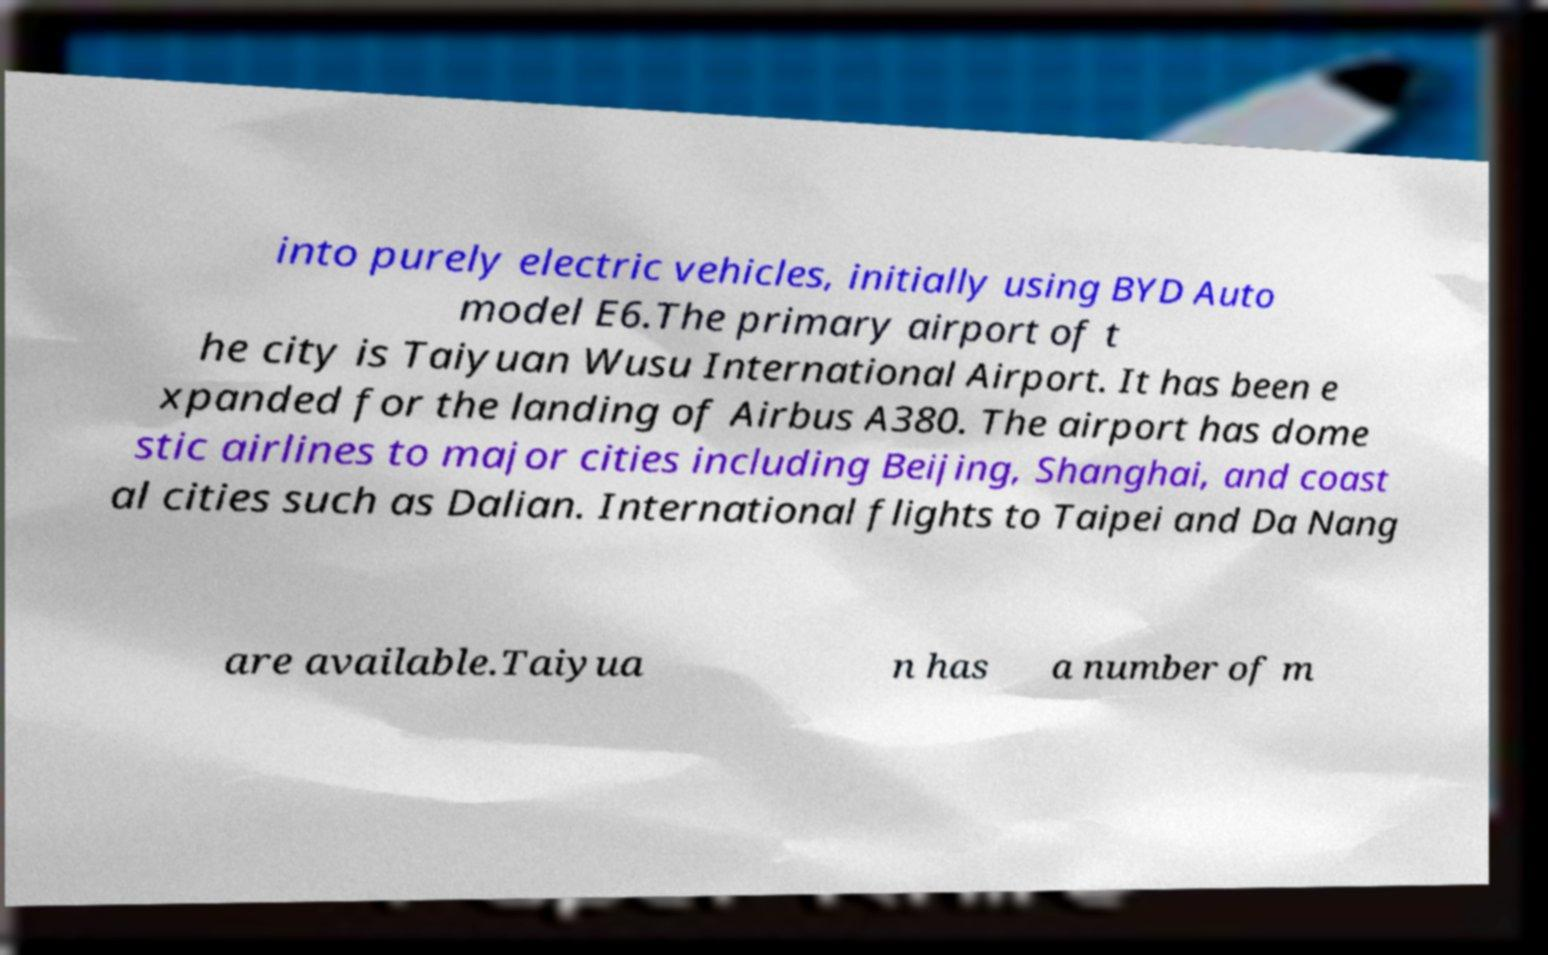For documentation purposes, I need the text within this image transcribed. Could you provide that? into purely electric vehicles, initially using BYD Auto model E6.The primary airport of t he city is Taiyuan Wusu International Airport. It has been e xpanded for the landing of Airbus A380. The airport has dome stic airlines to major cities including Beijing, Shanghai, and coast al cities such as Dalian. International flights to Taipei and Da Nang are available.Taiyua n has a number of m 